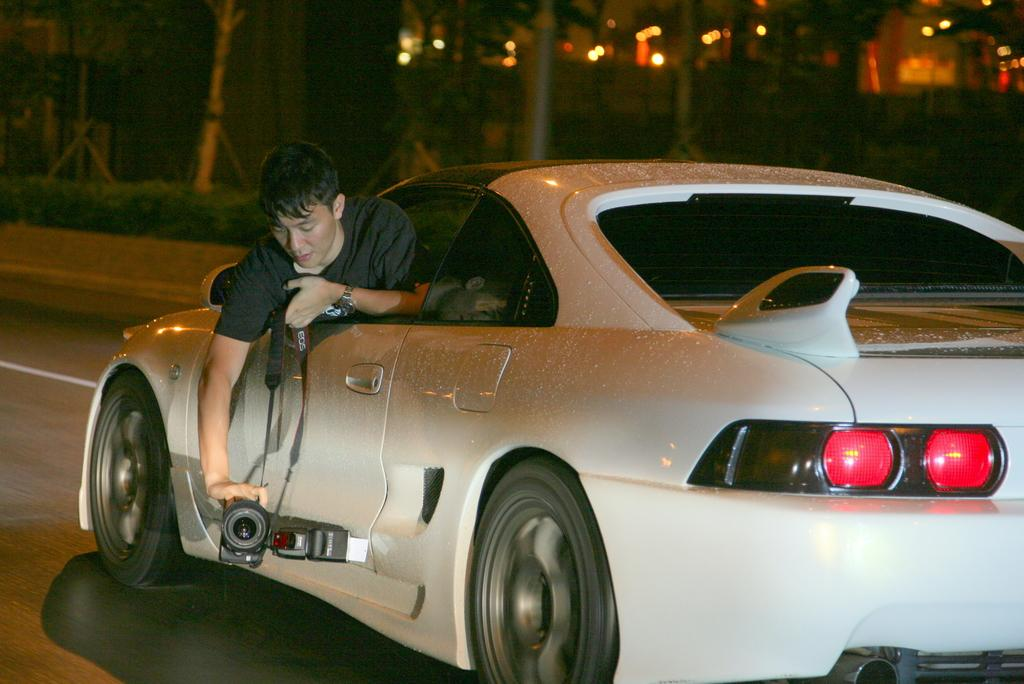What is the main subject of the image? The main subject of the image is a car. What is the car doing in the image? The car is moving in the image. Who is present in the image besides the car? There is a man in the image. What is the man holding in the image? The man is holding a video camera. How is the man positioned in relation to the car? The man is seen through a window in the image. What can be seen in the background of the image? There is a road, trees, and a building in the image. What color is the car in the image? The car is white in color. What type of winter sport is being played in the image? There is no winter sport or any indication of winter in the image. How often does the car get washed in the image? The image does not show the car being washed, nor does it provide any information about the frequency of car washes. 